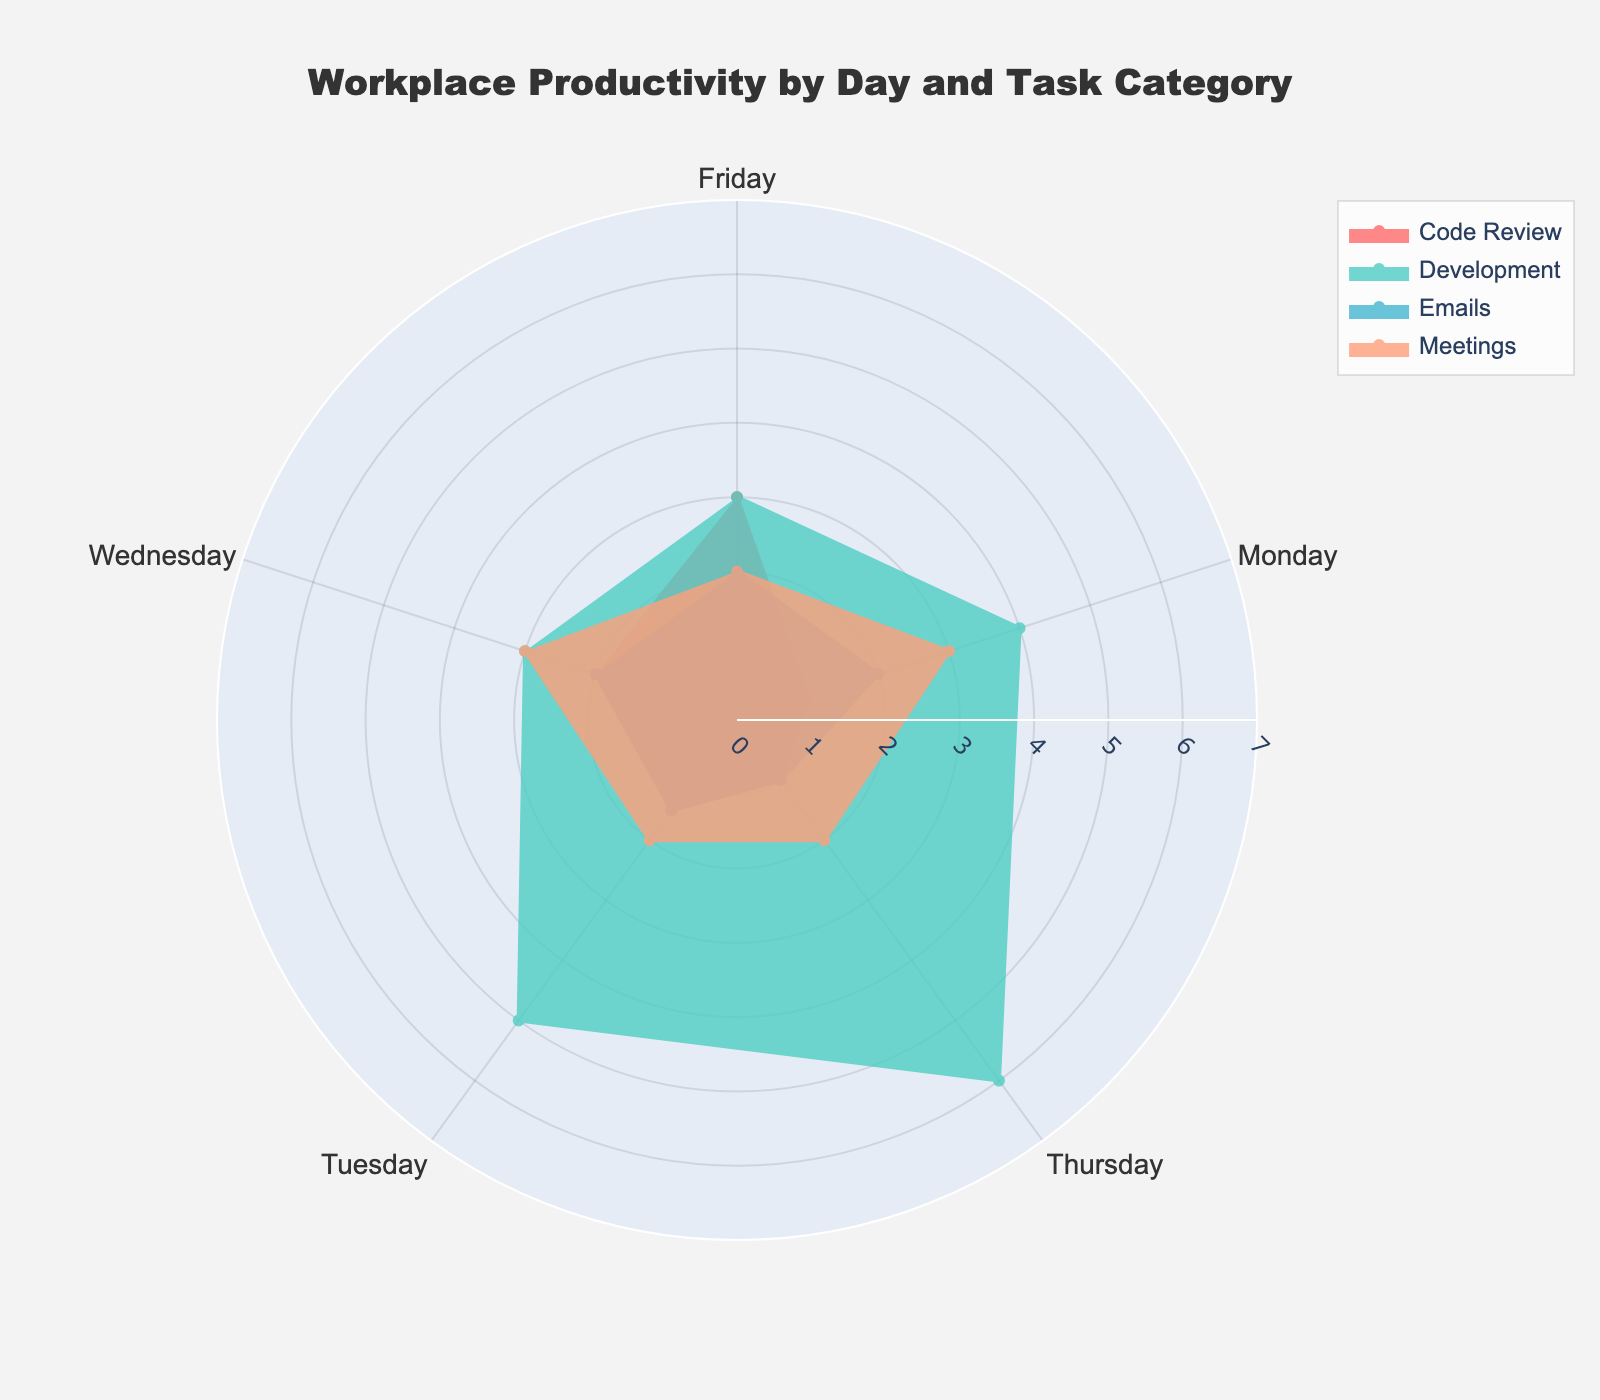What is the title of the chart? Look at the top of the figure for the text that describes the overall subject of the chart.
Answer: Workplace Productivity by Day and Task Category How many task categories are displayed in the chart? Identify the different shaded areas or legends corresponding to various tasks.
Answer: Four Which day has the highest number of hours spent on Development? Look for the largest radial extent of the Development category on the chart.
Answer: Thursday What is the total number of hours worked on meetings throughout the week? Sum the number of hours for meetings from Monday to Friday. Calculation: 3 + 2 + 3 + 2 + 2 = 12
Answer: 12 On which day is the total number of hours spent on all tasks the smallest? Sum the hours for each task category per day and compare to find the smallest total. Monday: 2+3+4+1=10, Tuesday: 1.5+2+5+1.5=10, Wednesday: 2+3+3+2=10, Thursday: 1+2+6+1=10, Friday: 2+2+3+3=10. All days have the same totals.
Answer: Every day has 10 hours Which task category has the least variability across the days? Analyze each task category’s distribution across the days and identify the one with the smallest variation. Emails fluctuate between 1 and 2 hours, while Code Review, for instance, goes from 1 to 3 hours.
Answer: Emails What is the average number of hours spent on Emails per day? Sum the hours spent on Emails from Monday to Friday and divide by the number of days. Calculation: (2+1.5+2+1+2)/5 = 1.7
Answer: 1.7 On which day is the total number of hours spent on Code Review the highest? Check which day has the largest radial distance for Code Review.
Answer: Friday Is there a day where more time is spent on Code Review than on Development? Compare the radial distances of Code Review and Development for each day to identify any such day. Code Review is less on all days compared to Development.
Answer: No What is the difference in hours spent on Development between Wednesday and Friday? Subtract the hours spent on Development on Wednesday from those on Friday. Calculation: 3 - 3 = 0
Answer: 0 